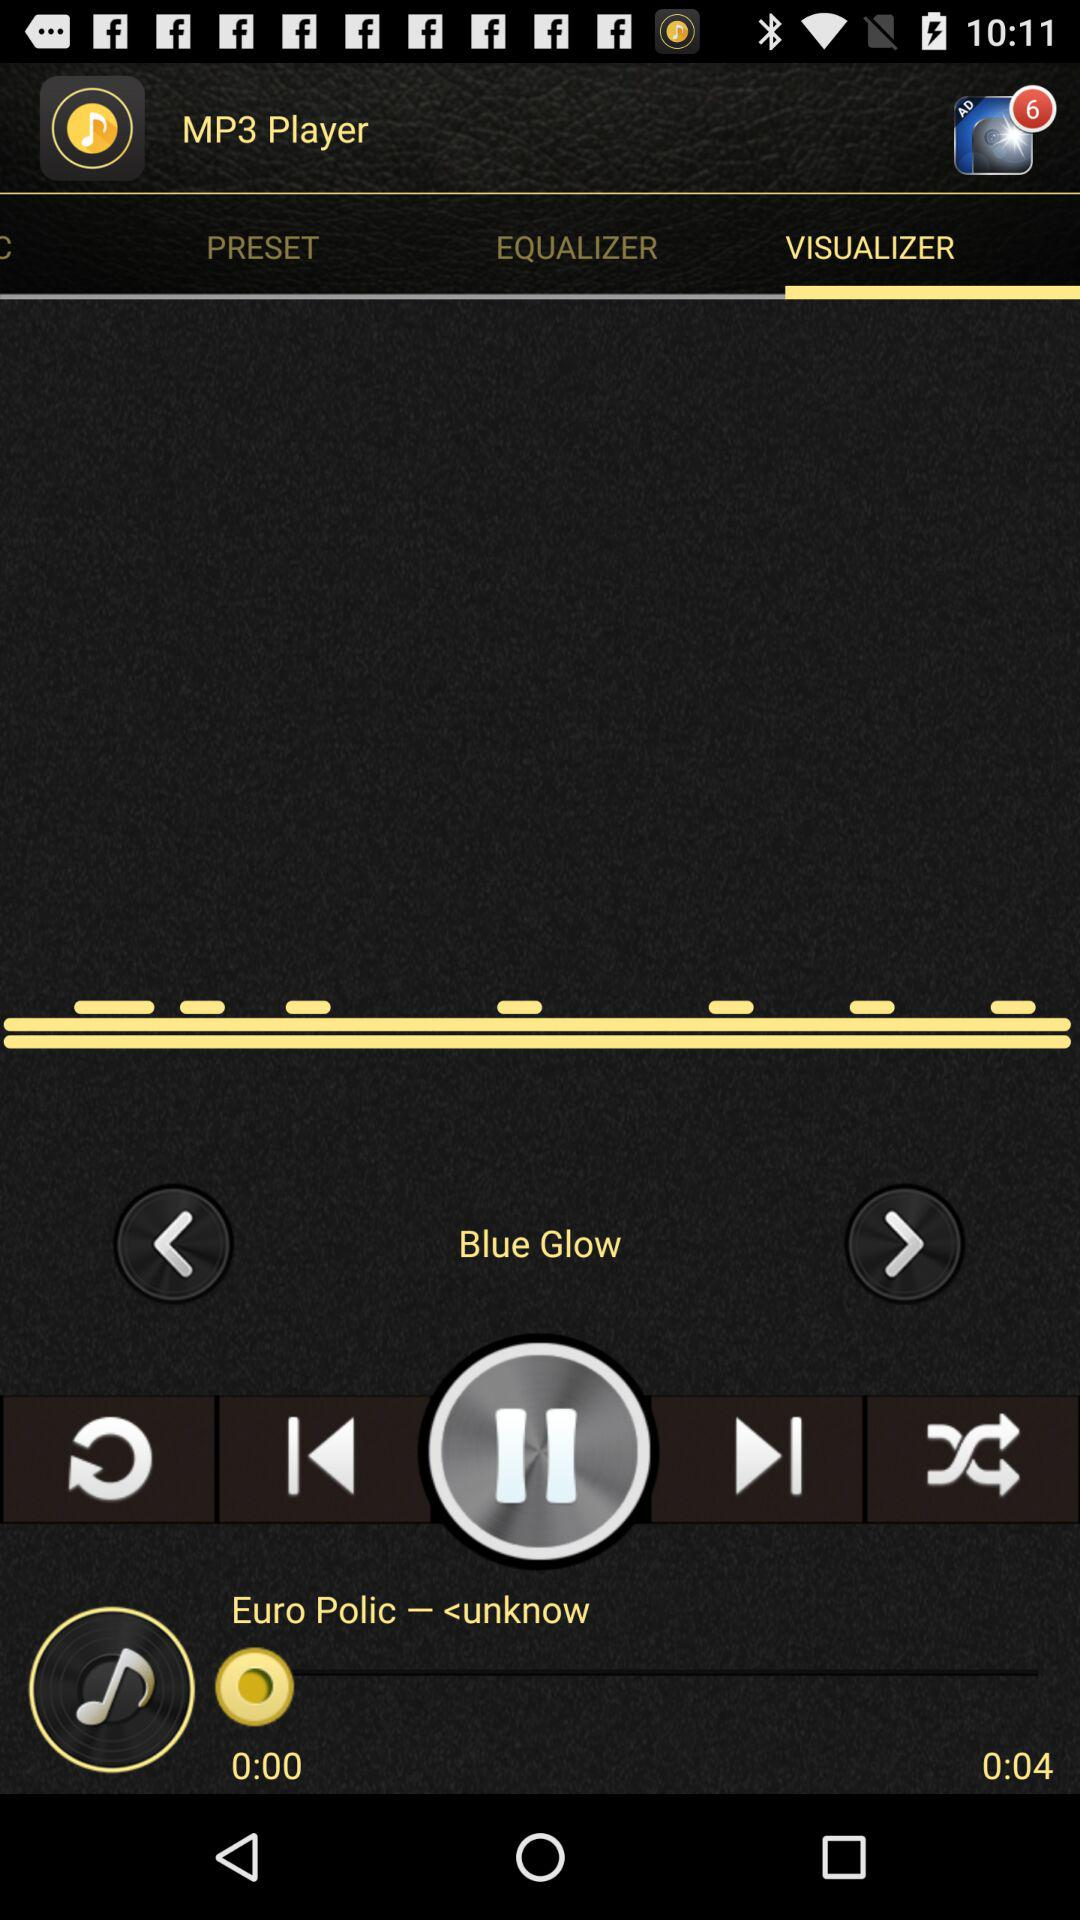What is the selected tab? The selected tab is "VISUALIZER". 